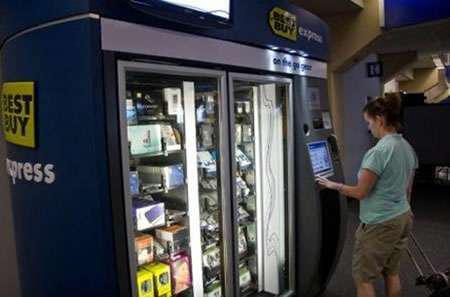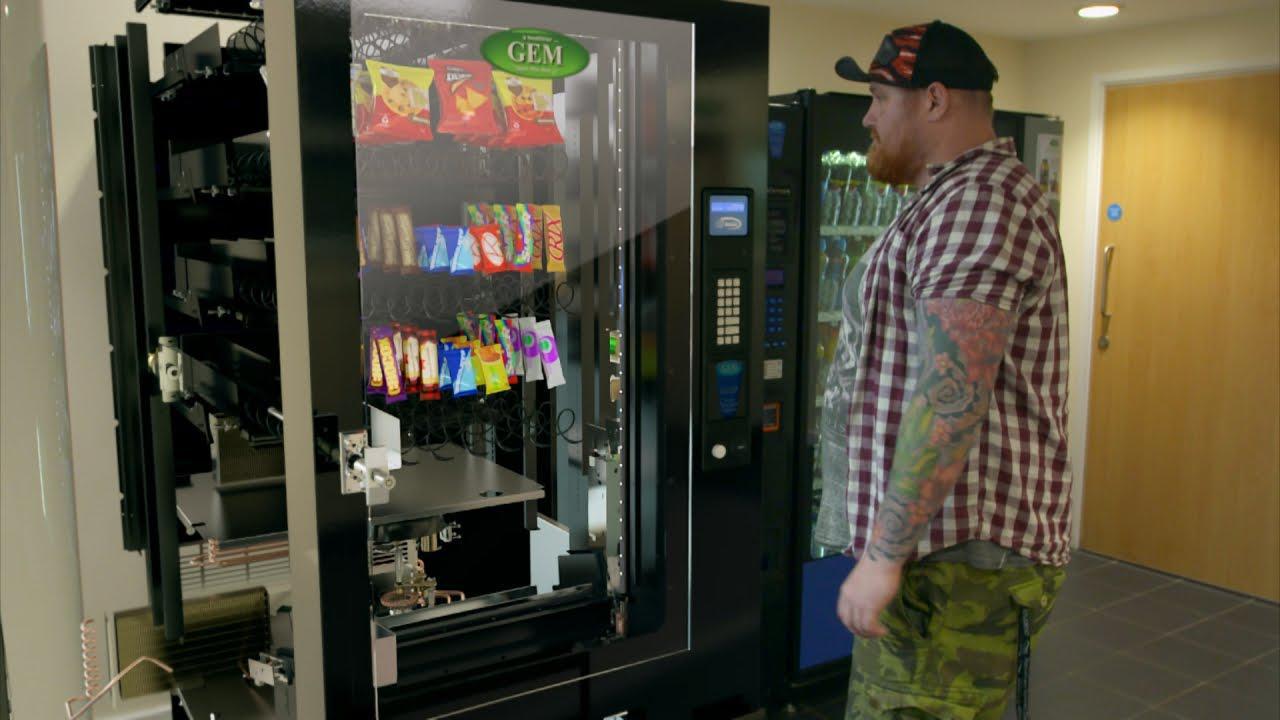The first image is the image on the left, the second image is the image on the right. For the images shown, is this caption "In one image, a row of three vending machines are the same height." true? Answer yes or no. No. 